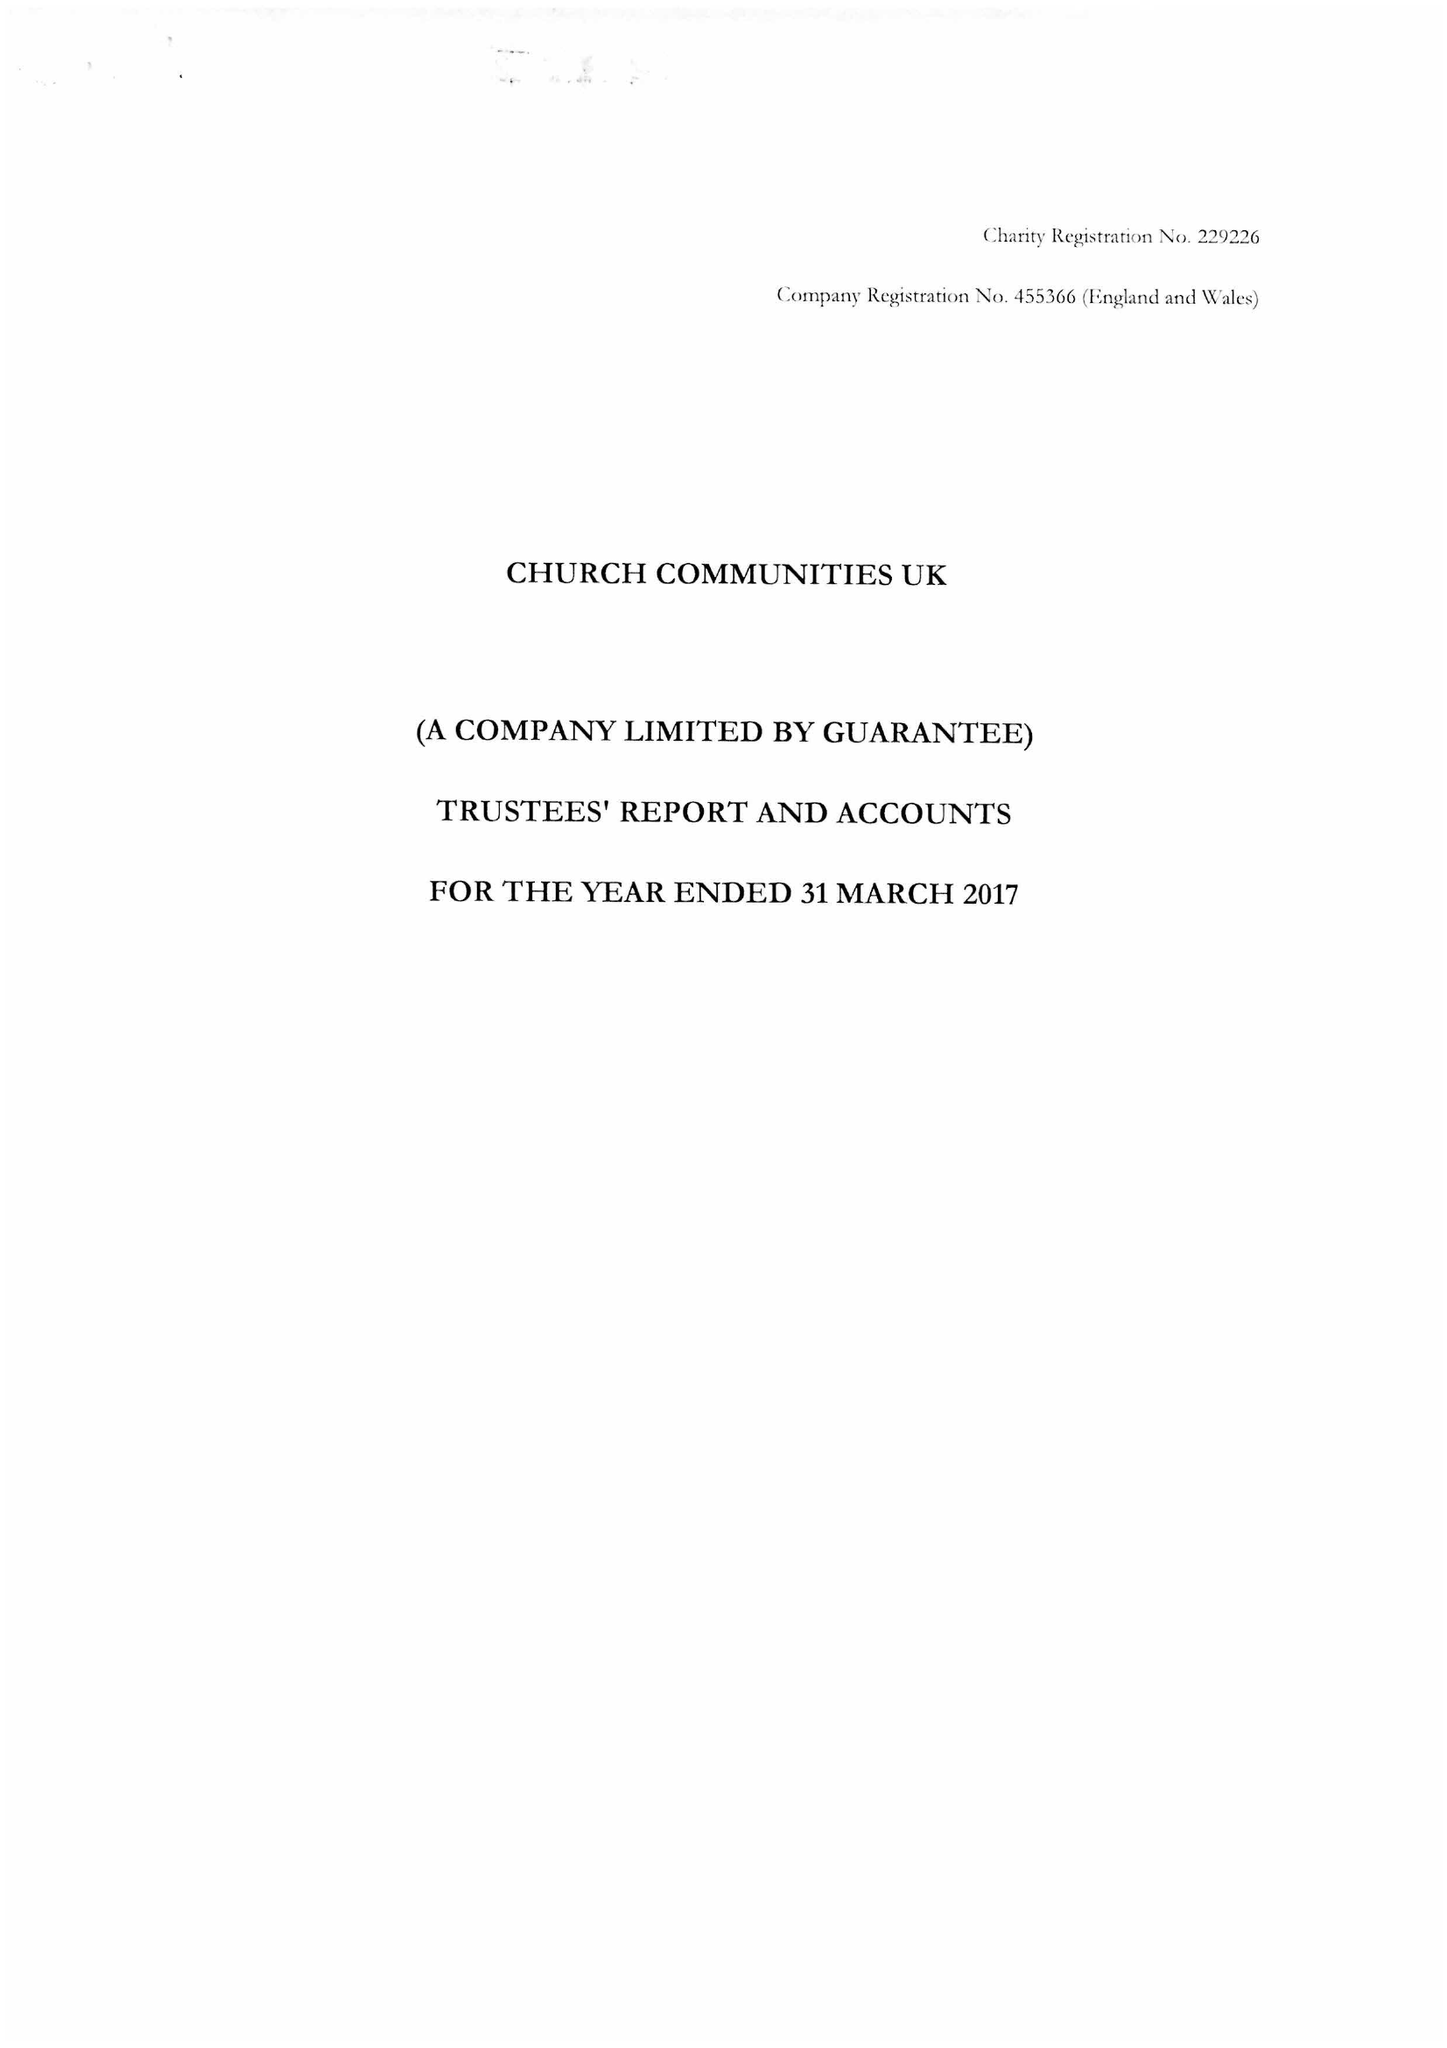What is the value for the report_date?
Answer the question using a single word or phrase. 2017-03-31 